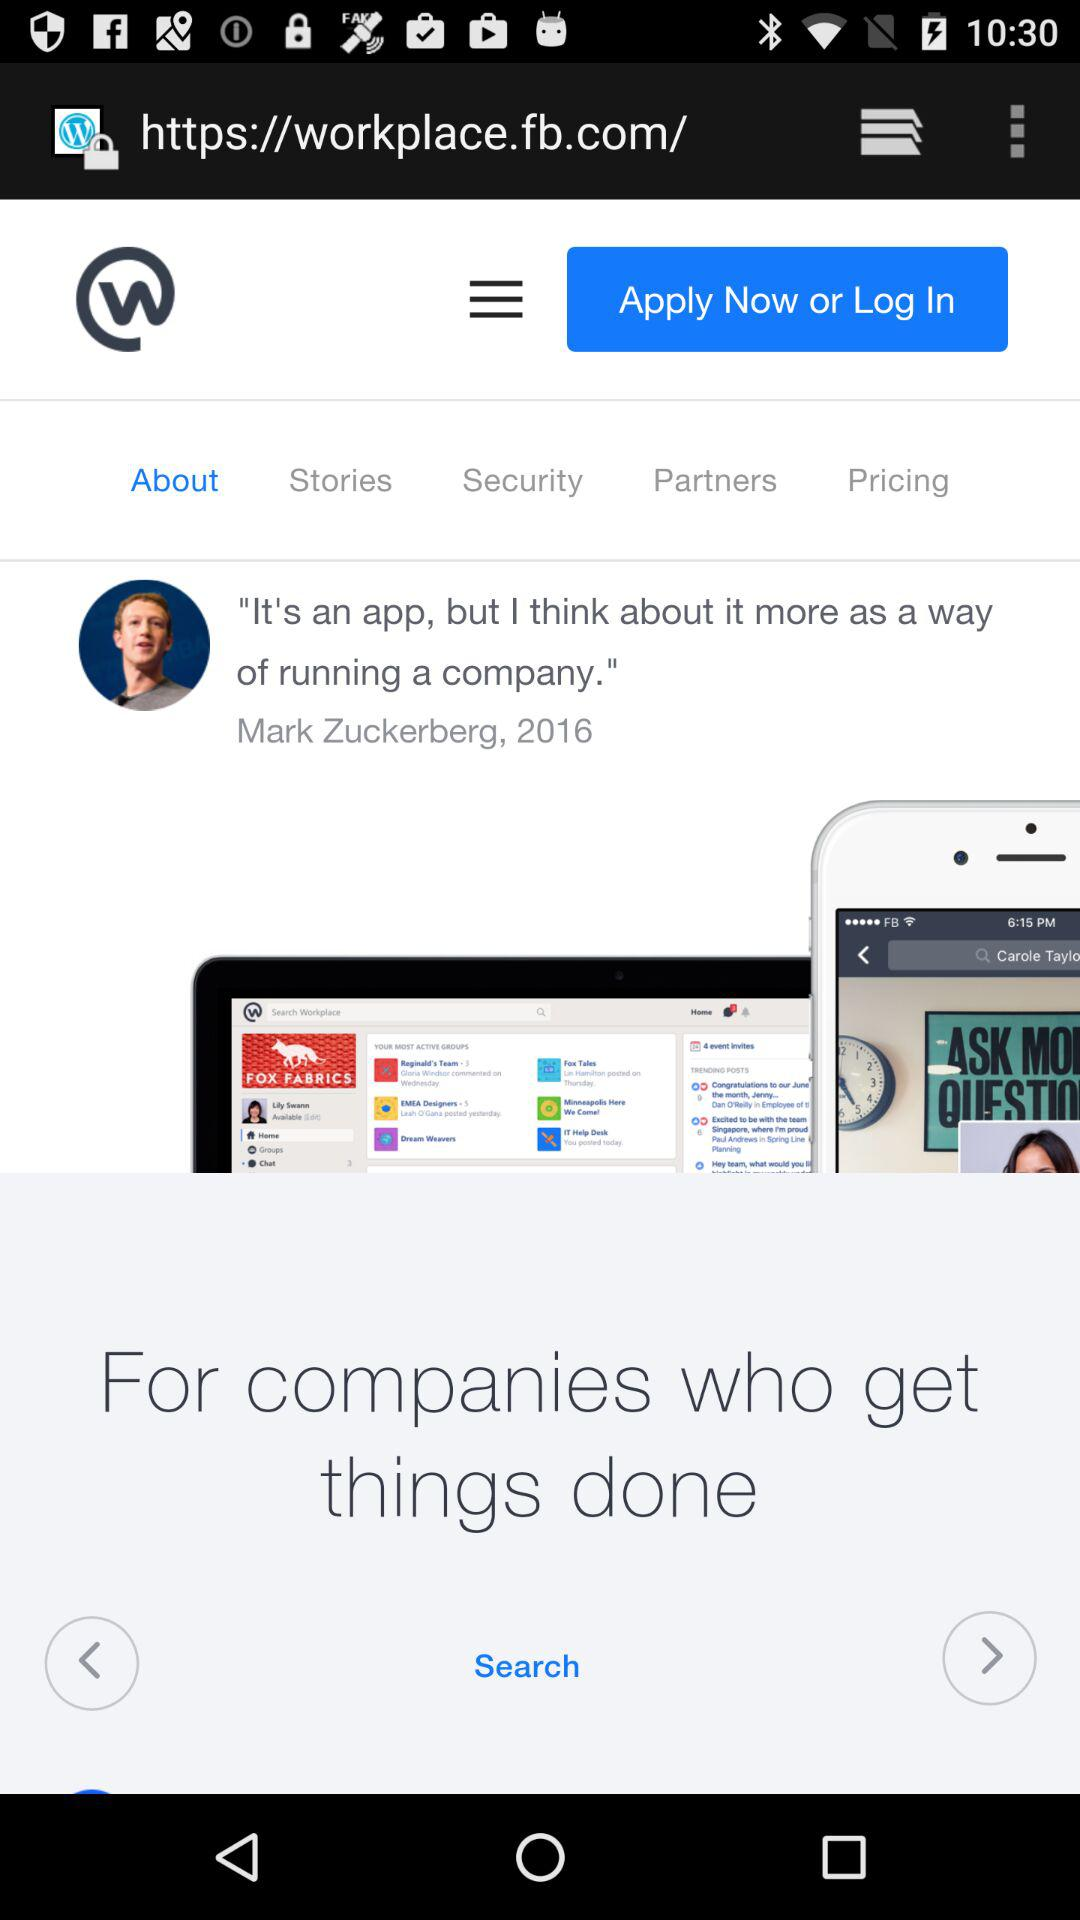When did Mark Zuckerberg say, "It's an app, but I think about it more as a way of running a company"? Mark Zuckerberg said, "It's an app, but I think about it more as a way of running a company" in 2016. 